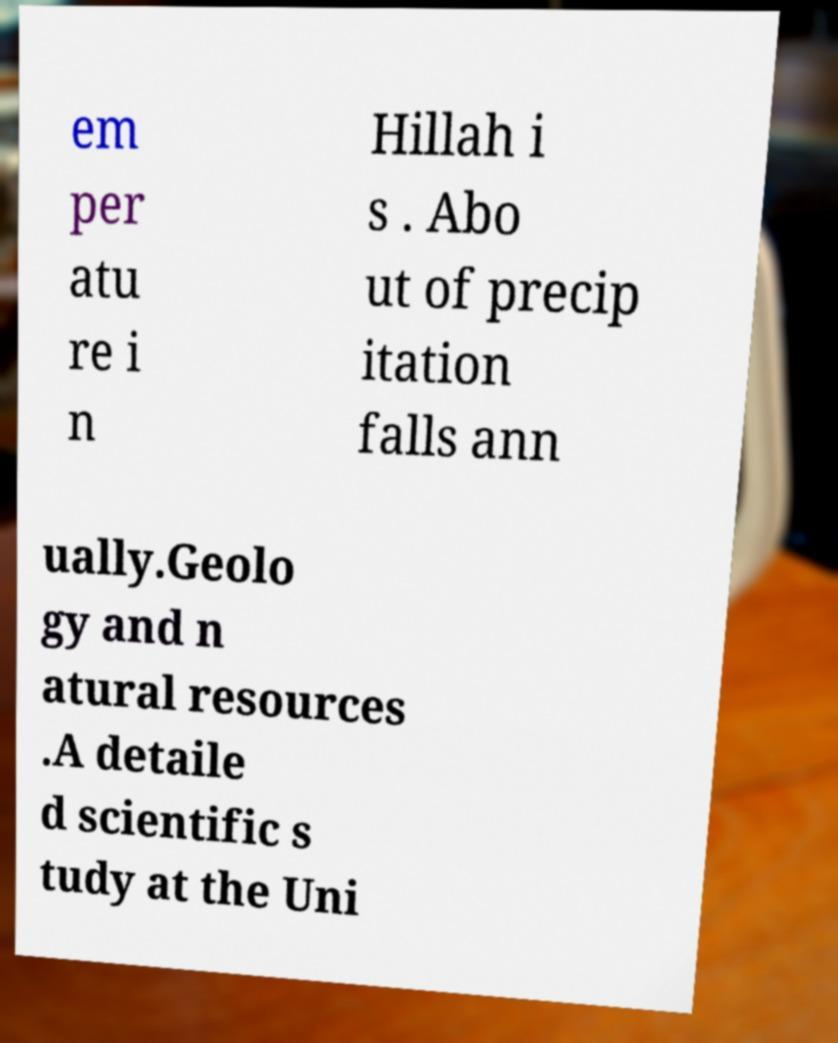Can you read and provide the text displayed in the image?This photo seems to have some interesting text. Can you extract and type it out for me? em per atu re i n Hillah i s . Abo ut of precip itation falls ann ually.Geolo gy and n atural resources .A detaile d scientific s tudy at the Uni 